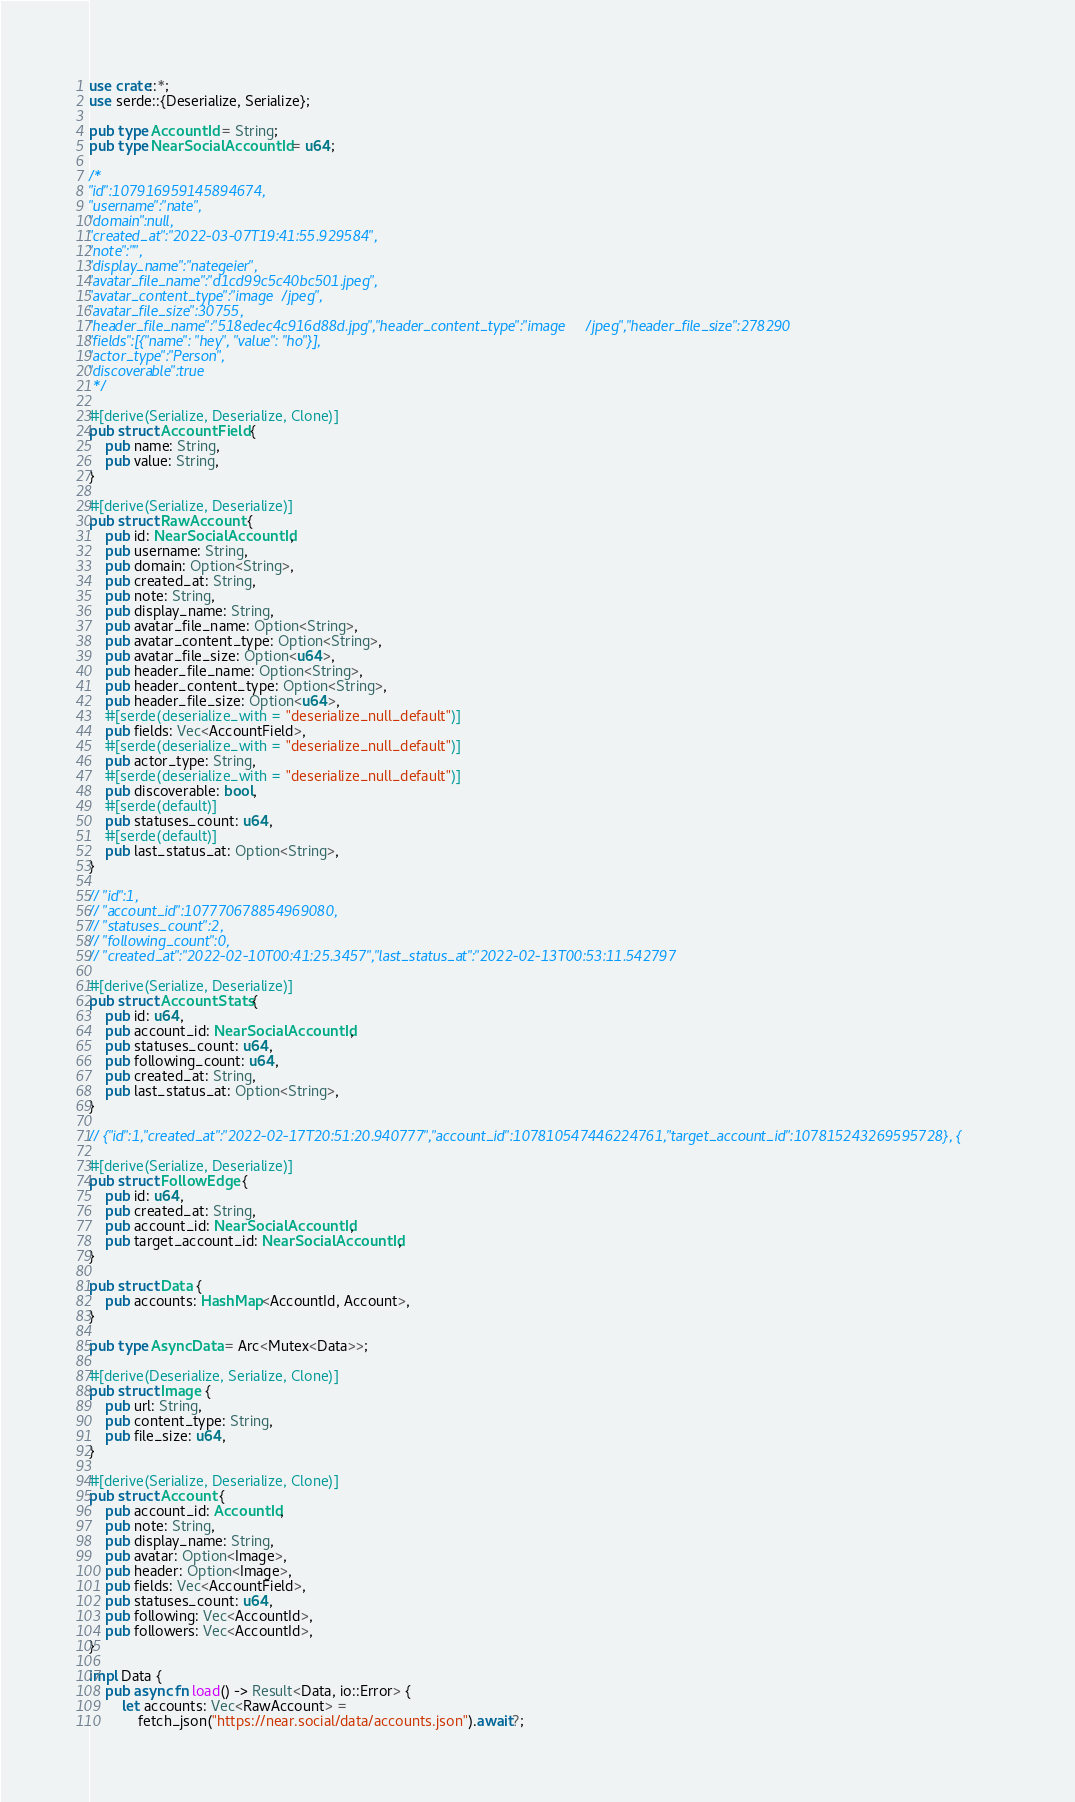<code> <loc_0><loc_0><loc_500><loc_500><_Rust_>use crate::*;
use serde::{Deserialize, Serialize};

pub type AccountId = String;
pub type NearSocialAccountId = u64;

/*
"id":107916959145894674,
"username":"nate",
"domain":null,
"created_at":"2022-03-07T19:41:55.929584",
"note":"",
"display_name":"nategeier",
"avatar_file_name":"d1cd99c5c40bc501.jpeg",
"avatar_content_type":"image/jpeg",
"avatar_file_size":30755,
"header_file_name":"518edec4c916d88d.jpg","header_content_type":"image/jpeg","header_file_size":278290
"fields":[{"name": "hey", "value": "ho"}],
"actor_type":"Person",
"discoverable":true
 */

#[derive(Serialize, Deserialize, Clone)]
pub struct AccountField {
    pub name: String,
    pub value: String,
}

#[derive(Serialize, Deserialize)]
pub struct RawAccount {
    pub id: NearSocialAccountId,
    pub username: String,
    pub domain: Option<String>,
    pub created_at: String,
    pub note: String,
    pub display_name: String,
    pub avatar_file_name: Option<String>,
    pub avatar_content_type: Option<String>,
    pub avatar_file_size: Option<u64>,
    pub header_file_name: Option<String>,
    pub header_content_type: Option<String>,
    pub header_file_size: Option<u64>,
    #[serde(deserialize_with = "deserialize_null_default")]
    pub fields: Vec<AccountField>,
    #[serde(deserialize_with = "deserialize_null_default")]
    pub actor_type: String,
    #[serde(deserialize_with = "deserialize_null_default")]
    pub discoverable: bool,
    #[serde(default)]
    pub statuses_count: u64,
    #[serde(default)]
    pub last_status_at: Option<String>,
}

// "id":1,
// "account_id":107770678854969080,
// "statuses_count":2,
// "following_count":0,
// "created_at":"2022-02-10T00:41:25.3457","last_status_at":"2022-02-13T00:53:11.542797

#[derive(Serialize, Deserialize)]
pub struct AccountStats {
    pub id: u64,
    pub account_id: NearSocialAccountId,
    pub statuses_count: u64,
    pub following_count: u64,
    pub created_at: String,
    pub last_status_at: Option<String>,
}

// {"id":1,"created_at":"2022-02-17T20:51:20.940777","account_id":107810547446224761,"target_account_id":107815243269595728}, {

#[derive(Serialize, Deserialize)]
pub struct FollowEdge {
    pub id: u64,
    pub created_at: String,
    pub account_id: NearSocialAccountId,
    pub target_account_id: NearSocialAccountId,
}

pub struct Data {
    pub accounts: HashMap<AccountId, Account>,
}

pub type AsyncData = Arc<Mutex<Data>>;

#[derive(Deserialize, Serialize, Clone)]
pub struct Image {
    pub url: String,
    pub content_type: String,
    pub file_size: u64,
}

#[derive(Serialize, Deserialize, Clone)]
pub struct Account {
    pub account_id: AccountId,
    pub note: String,
    pub display_name: String,
    pub avatar: Option<Image>,
    pub header: Option<Image>,
    pub fields: Vec<AccountField>,
    pub statuses_count: u64,
    pub following: Vec<AccountId>,
    pub followers: Vec<AccountId>,
}

impl Data {
    pub async fn load() -> Result<Data, io::Error> {
        let accounts: Vec<RawAccount> =
            fetch_json("https://near.social/data/accounts.json").await?;</code> 